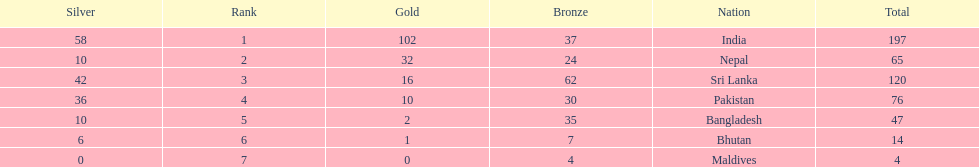Name the first country on the table? India. 